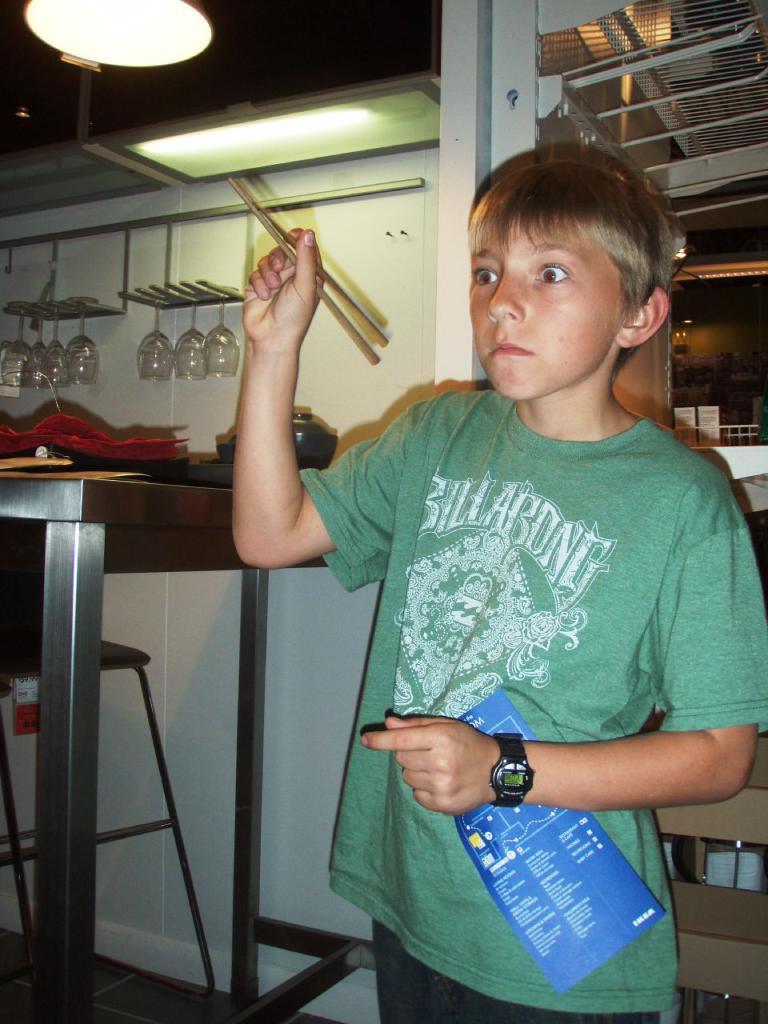Describe this image in one or two sentences. In this picture we can see boy holding chopsticks in hand and paper on other hand and in the background we can see glasses, table, bowl, light, racks, chair. 